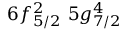Convert formula to latex. <formula><loc_0><loc_0><loc_500><loc_500>6 f _ { 5 / 2 } ^ { 2 } \, 5 g _ { 7 / 2 } ^ { 4 }</formula> 